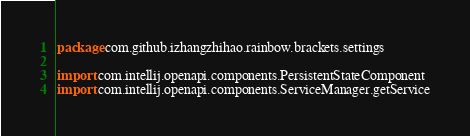Convert code to text. <code><loc_0><loc_0><loc_500><loc_500><_Kotlin_>package com.github.izhangzhihao.rainbow.brackets.settings

import com.intellij.openapi.components.PersistentStateComponent
import com.intellij.openapi.components.ServiceManager.getService</code> 